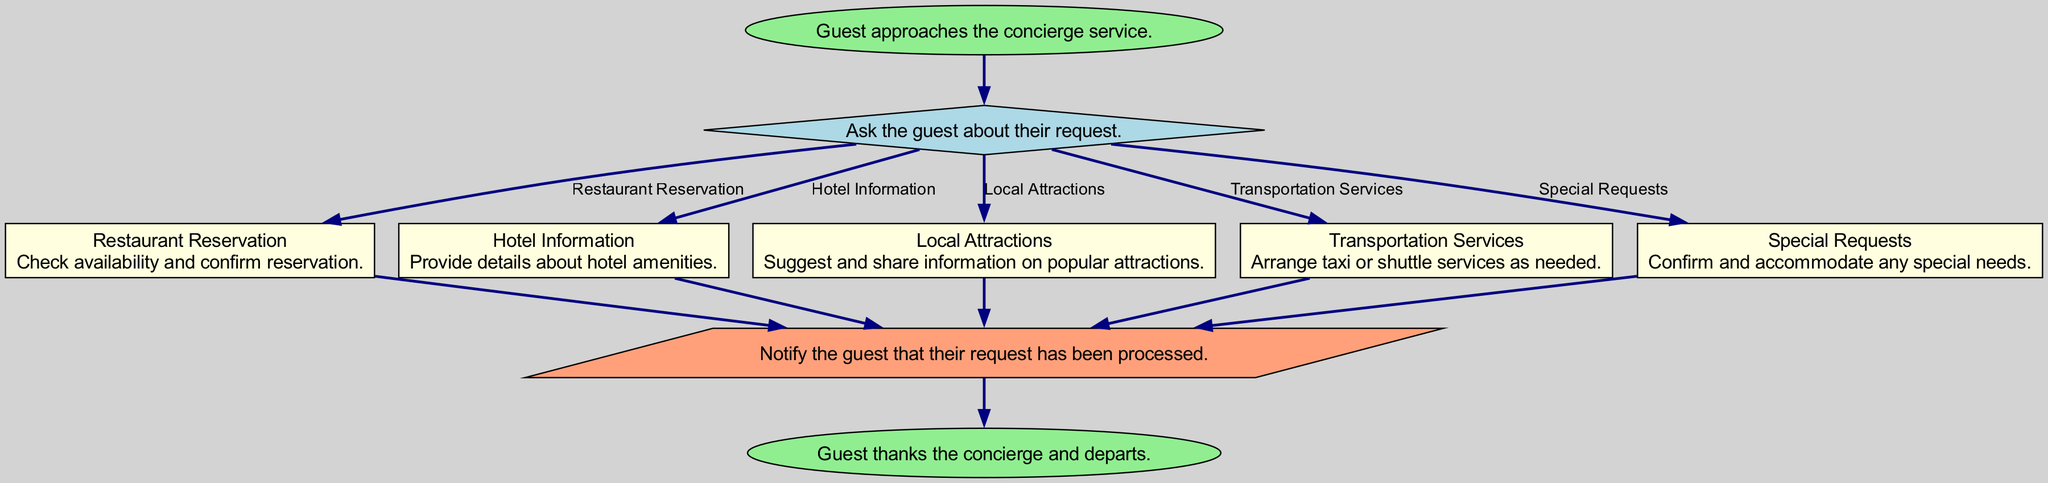What is the starting point of the concierge service flow? The starting point is indicated in the diagram as "Guest approaches the concierge service". This is the first node before any other actions are taken.
Answer: Guest approaches the concierge service How many options are there for identifying needs? The diagram presents five options under "Ask the guest about their request", representing different services. Counting these options yields the total number.
Answer: 5 What is the action taken for a restaurant reservation? According to the diagram, the action for a restaurant reservation is to "Check availability and confirm reservation.” This describes what the concierge does in response to that specific request.
Answer: Check availability and confirm reservation What does the concierge do after processing any request? The next action described in the diagram is "Notify the guest that their request has been processed". This follows after the specific needs have been addressed.
Answer: Notify the guest that their request has been processed Which node is connected to the "Identify Need" node with the label "Transportation Services"? The "Transportation Services" node directly flows from the "Identify Need" node. The edge shows it is one of the options available for the guest's requests.
Answer: Transportation Services What happens at the end of the concierge service flow? The last node in the flow chart is titled "Guest thanks the concierge and departs." This summarizes the conclusion of the service interaction.
Answer: Guest thanks the concierge and departs Which shapes are used in the diagram for different types of actions? The diagram categorizes nodes by shape: ovals for the start and end, diamonds for identifying needs, and parallelograms for confirming requests. This shows varying actions throughout the flow.
Answer: Ovals, diamonds, parallelograms How many types of requests are processed in the concierge service flow? The diagram lists five specific types of requests that can be processed as identified in the options from the "Identify Need" node. These represent distinct categories of services offered.
Answer: 5 